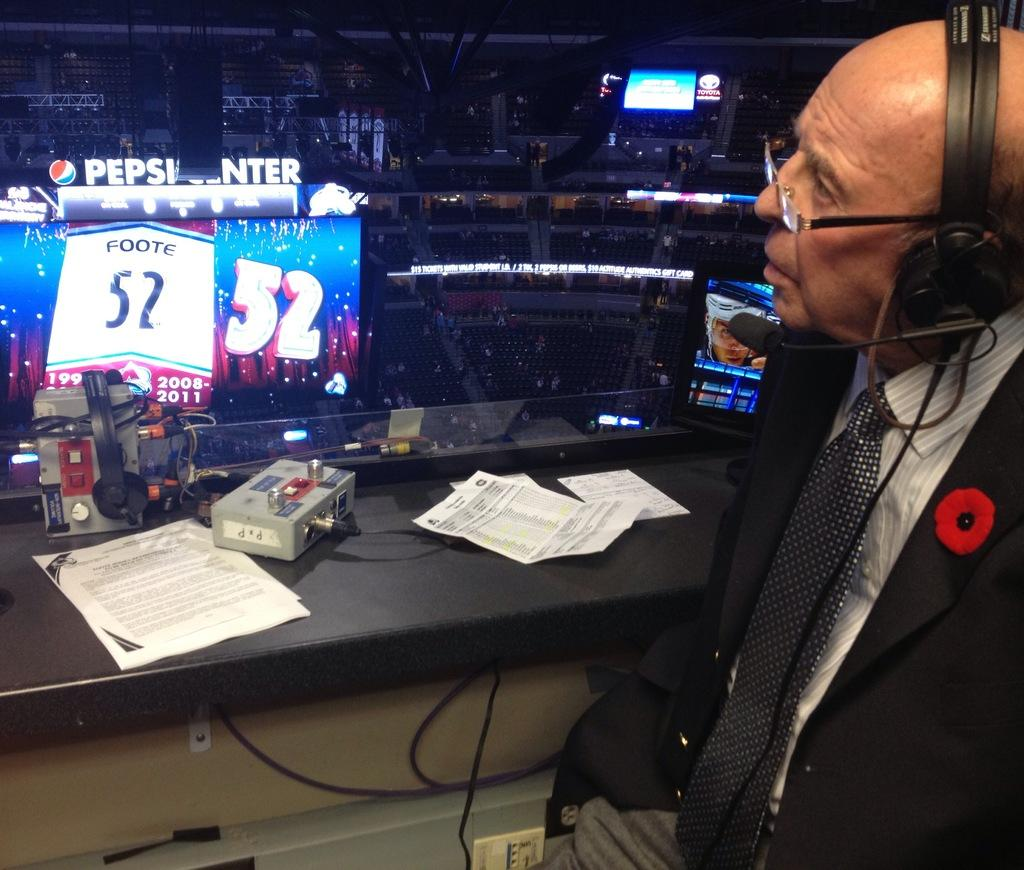<image>
Describe the image concisely. A sports caster looks out over the large Pepsi Center stadium. 